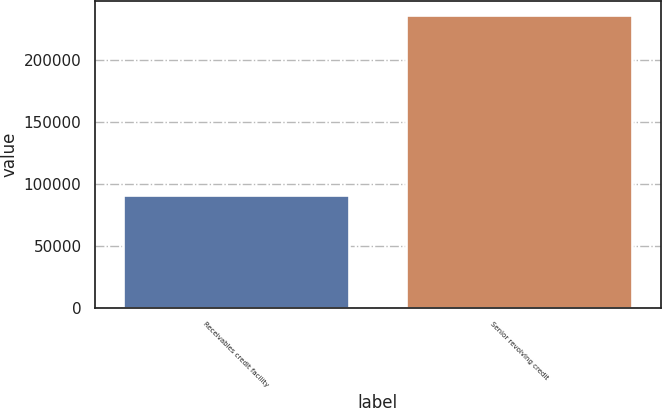Convert chart to OTSL. <chart><loc_0><loc_0><loc_500><loc_500><bar_chart><fcel>Receivables credit facility<fcel>Senior revolving credit<nl><fcel>91000<fcel>235688<nl></chart> 